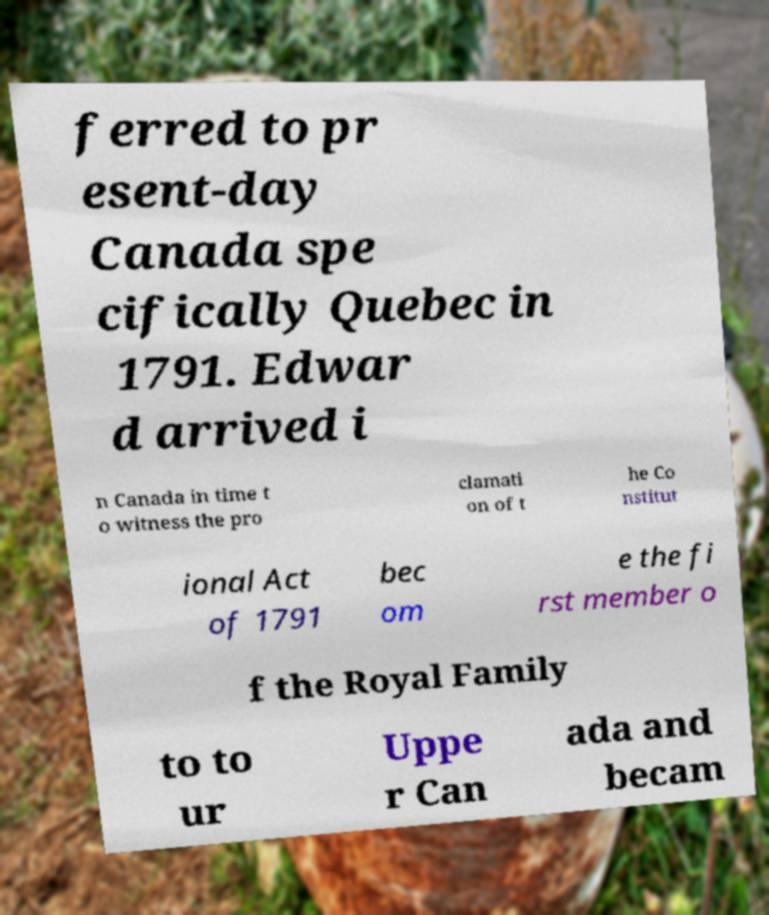Can you accurately transcribe the text from the provided image for me? ferred to pr esent-day Canada spe cifically Quebec in 1791. Edwar d arrived i n Canada in time t o witness the pro clamati on of t he Co nstitut ional Act of 1791 bec om e the fi rst member o f the Royal Family to to ur Uppe r Can ada and becam 